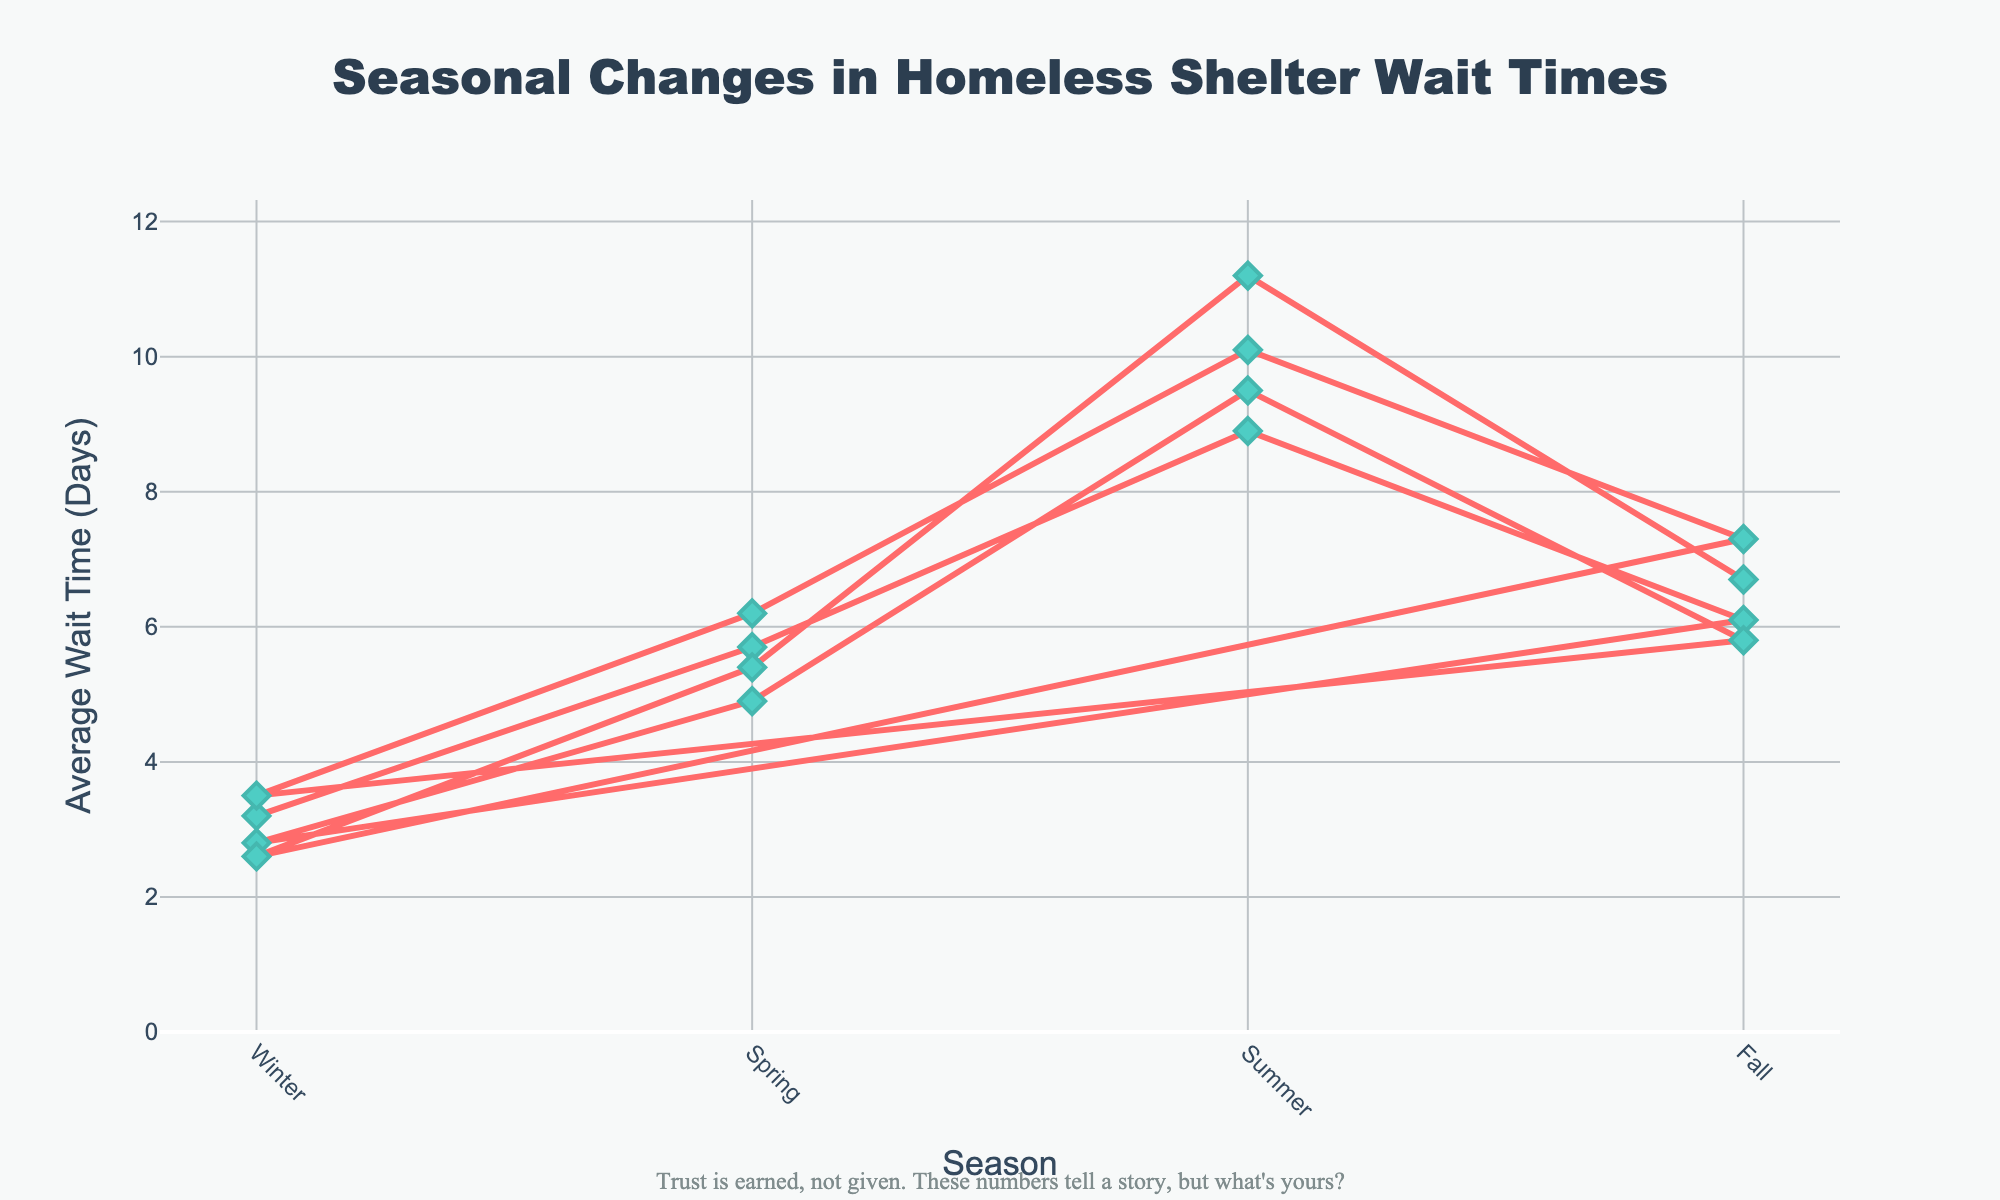Which season had the highest average wait time? To find the season with the highest average wait time, we look for the tallest point on the line chart, which represents the peak on the y-axis. In this case, the highest point corresponds to "Summer" with an average wait time above 11 days.
Answer: Summer Which season had the lowest average wait time? To determine the lowest average wait time, we search for the shortest point on the line chart, which indicates the minimum value on the y-axis. The lowest point is "Winter" with a wait time of 2.6 days.
Answer: Winter What is the difference in average wait times between Winter and Summer? Identify the average wait times for Winter and Summer, which are approximately 2.6 days and 11.2 days, respectively. Subtract the Winter value from the Summer value: 11.2 - 2.6 = 8.6 days.
Answer: 8.6 days Which season saw the most significant increase in average wait time compared to the previous one? Compare the height of the points across the seasons, focusing on the increase between consecutive points. The most significant increase is from Spring to Summer, from about 5.4 days to approximately 11.2 days, resulting in an increase of 5.8 days.
Answer: Spring to Summer What is the average wait time for Fall across all years? To find the average wait time for Fall, locate the wait times for Fall across different years: 6.1, 5.8, 7.3, and 6.7 days. Sum them up and divide by the number of observations: (6.1 + 5.8 + 7.3 + 6.7) / 4 = 25.9 / 4 = 6.475 days.
Answer: 6.475 days In which year did the average wait time for Winter drop the most compared to the previous year? Assess the average wait times for Winter across the years: 3.2, 2.8, 3.5, and 2.6 days. The most significant drop is from 3.5 to 2.6 days, which occurred between the third and fourth years.
Answer: Third to Fourth year What is the trend of average wait times for Summer over the years? Look at the points representing Summer over the years: 8.9, 9.5, 10.1, and 11.2 days. The trend shows a consistent increase each year.
Answer: Increasing How does the average wait time for Spring in the first year compare to Fall in the last year? Identify the average wait time for Spring in the first year (5.7 days) and Fall in the last year (6.7 days). Comparing these values, Fall in the last year has a higher average wait time.
Answer: Fall in the last year is higher What is the average wait time across all seasons in the third year? Sum the average wait times for the third year: Winter (3.5), Spring (6.2), Summer (10.1), and Fall (7.3) days. Calculate the average by dividing the sum by four: (3.5 + 6.2 + 10.1 + 7.3) / 4 = 27.1 / 4 = 6.775 days.
Answer: 6.775 days 